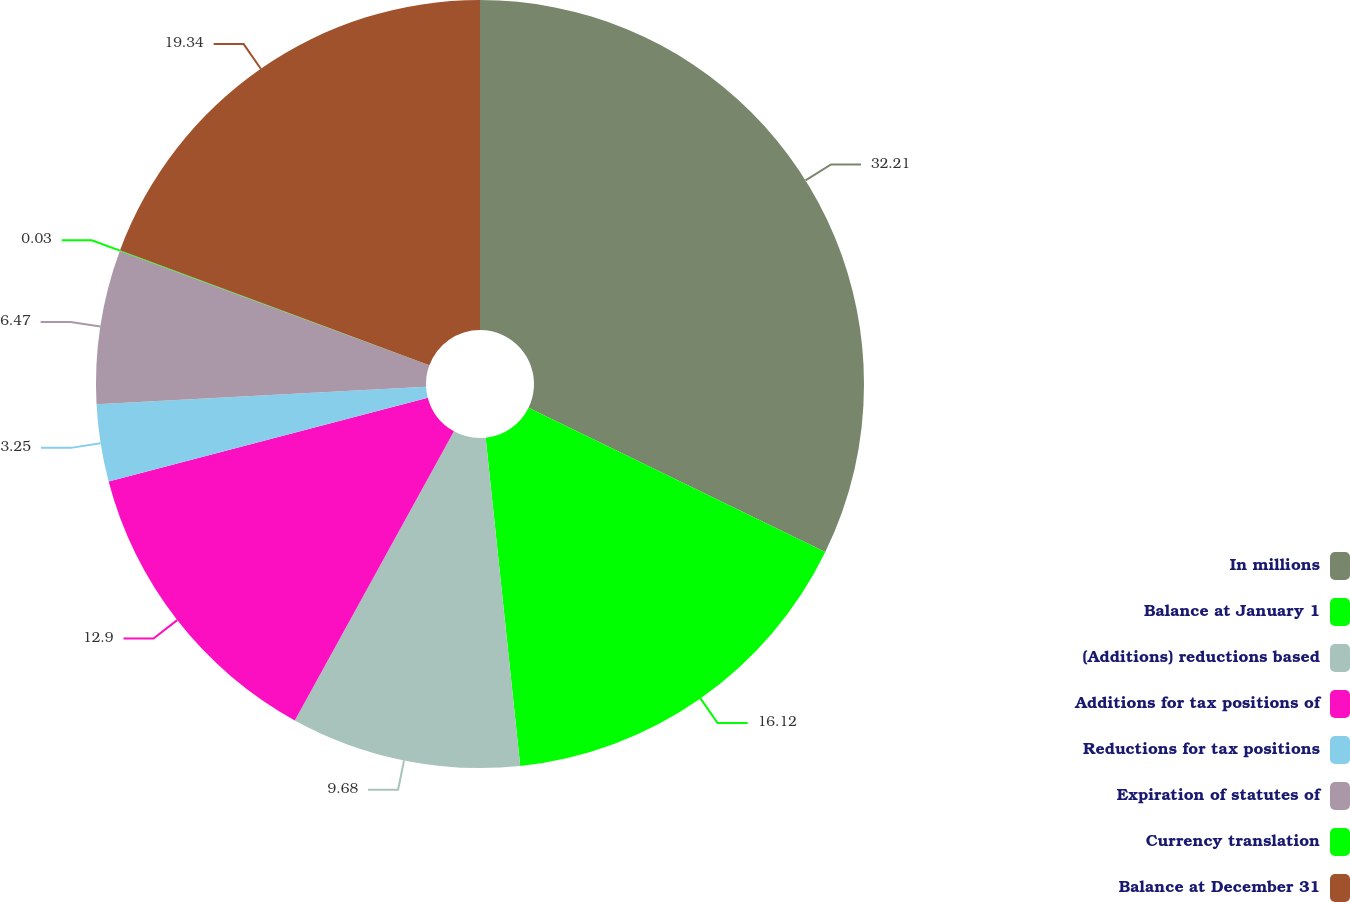Convert chart to OTSL. <chart><loc_0><loc_0><loc_500><loc_500><pie_chart><fcel>In millions<fcel>Balance at January 1<fcel>(Additions) reductions based<fcel>Additions for tax positions of<fcel>Reductions for tax positions<fcel>Expiration of statutes of<fcel>Currency translation<fcel>Balance at December 31<nl><fcel>32.21%<fcel>16.12%<fcel>9.68%<fcel>12.9%<fcel>3.25%<fcel>6.47%<fcel>0.03%<fcel>19.34%<nl></chart> 